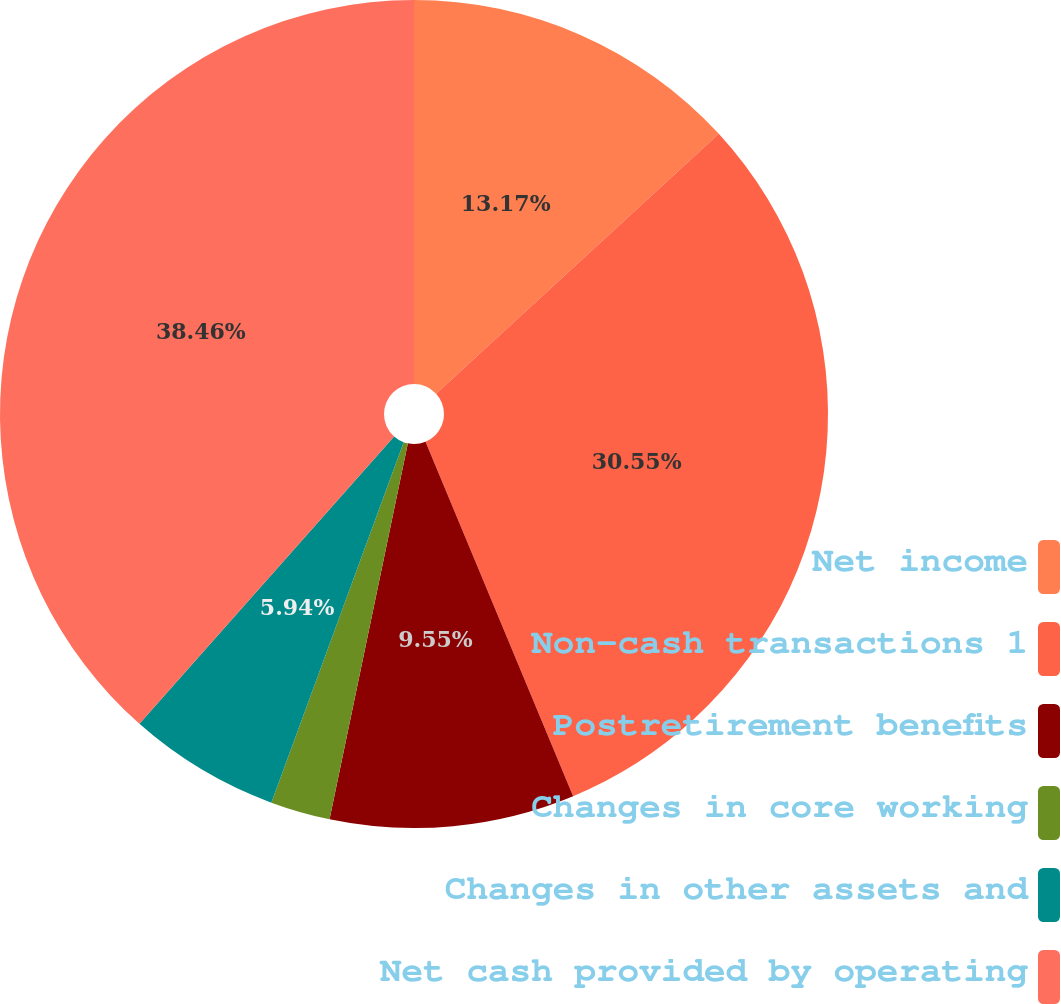Convert chart to OTSL. <chart><loc_0><loc_0><loc_500><loc_500><pie_chart><fcel>Net income<fcel>Non-cash transactions 1<fcel>Postretirement benefits<fcel>Changes in core working<fcel>Changes in other assets and<fcel>Net cash provided by operating<nl><fcel>13.17%<fcel>30.55%<fcel>9.55%<fcel>2.33%<fcel>5.94%<fcel>38.46%<nl></chart> 